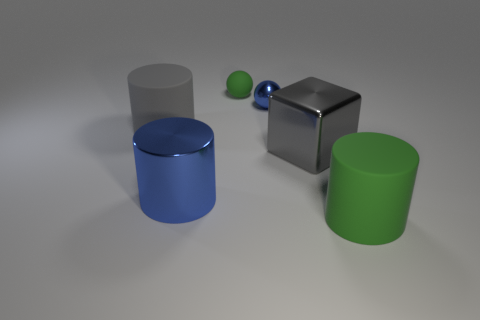Subtract all rubber cylinders. How many cylinders are left? 1 Add 4 gray blocks. How many objects exist? 10 Add 1 blue cylinders. How many blue cylinders are left? 2 Add 2 gray cylinders. How many gray cylinders exist? 3 Subtract all gray cylinders. How many cylinders are left? 2 Subtract 0 blue blocks. How many objects are left? 6 Subtract all balls. How many objects are left? 4 Subtract 1 balls. How many balls are left? 1 Subtract all yellow blocks. Subtract all cyan cylinders. How many blocks are left? 1 Subtract all yellow blocks. How many cyan cylinders are left? 0 